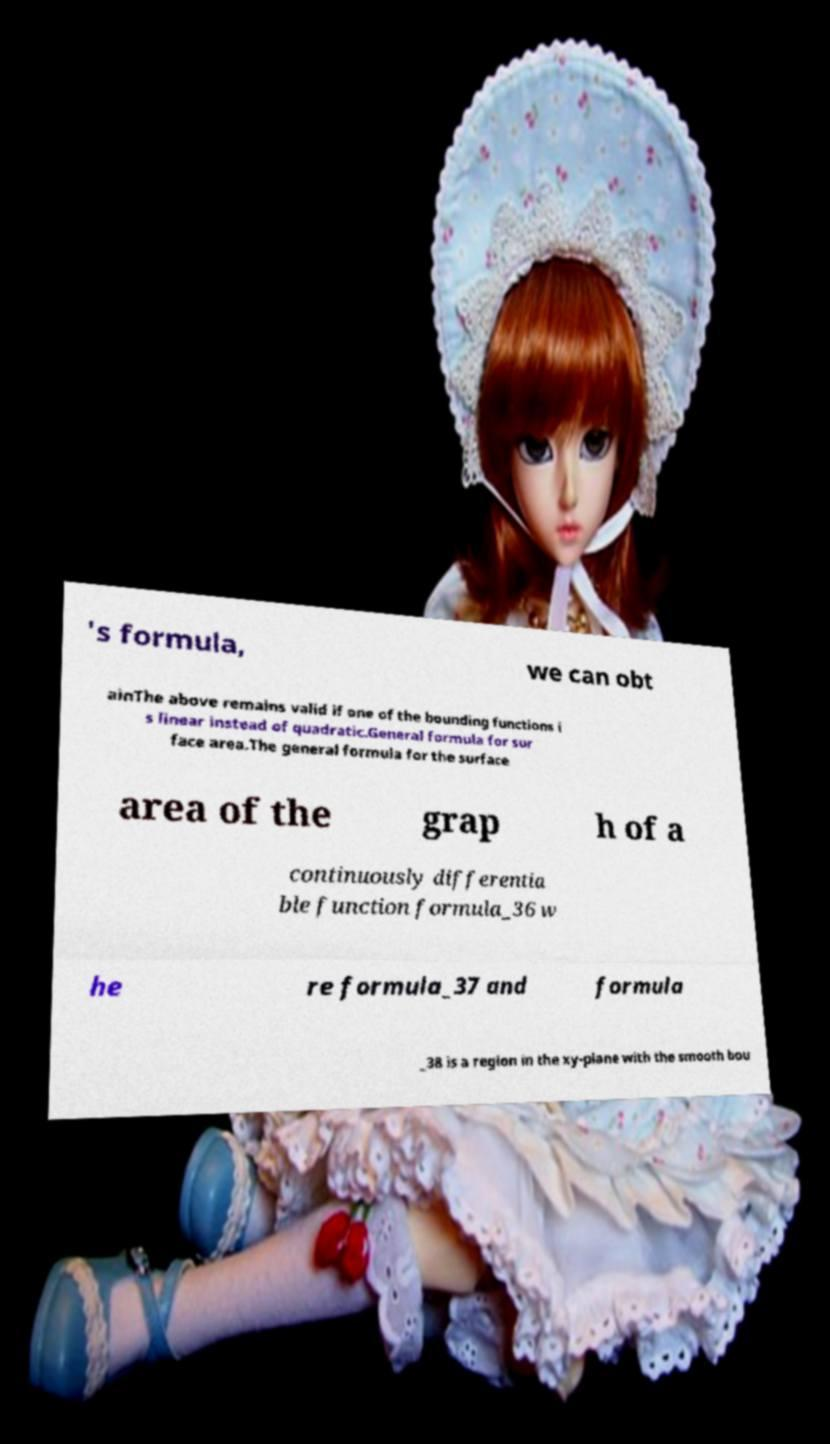For documentation purposes, I need the text within this image transcribed. Could you provide that? 's formula, we can obt ainThe above remains valid if one of the bounding functions i s linear instead of quadratic.General formula for sur face area.The general formula for the surface area of the grap h of a continuously differentia ble function formula_36 w he re formula_37 and formula _38 is a region in the xy-plane with the smooth bou 